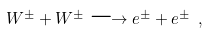Convert formula to latex. <formula><loc_0><loc_0><loc_500><loc_500>W ^ { \pm } + W ^ { \pm } \longrightarrow e ^ { \pm } + e ^ { \pm } \ ,</formula> 